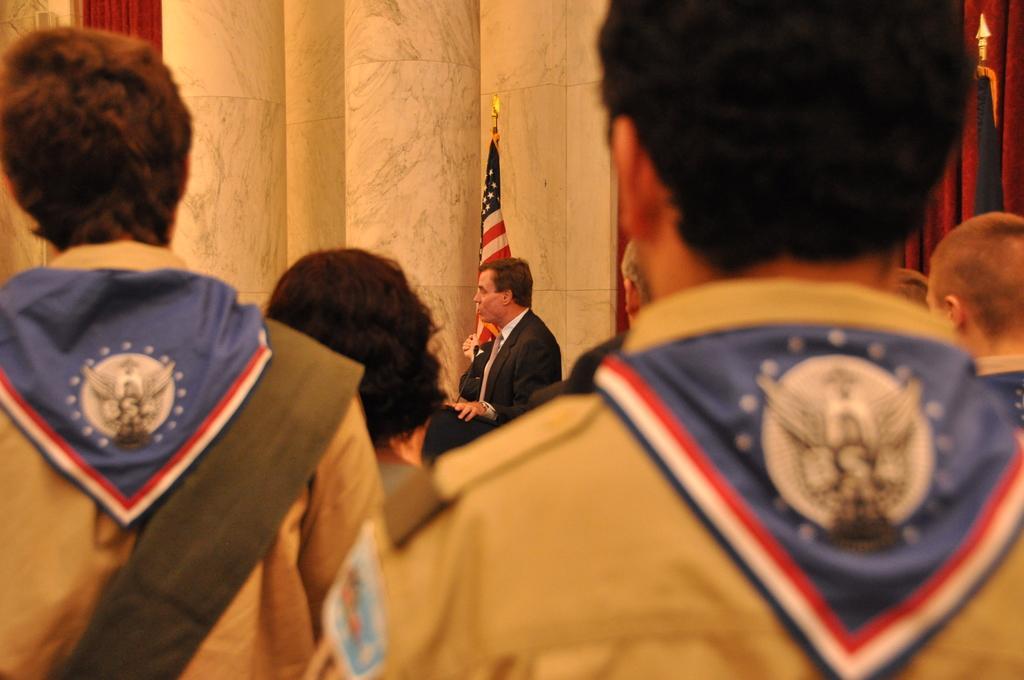Could you give a brief overview of what you see in this image? In this image I can see people standing, facing their back. A person is standing in the center, wearing a suit. There is a flag and pillars at the back. 